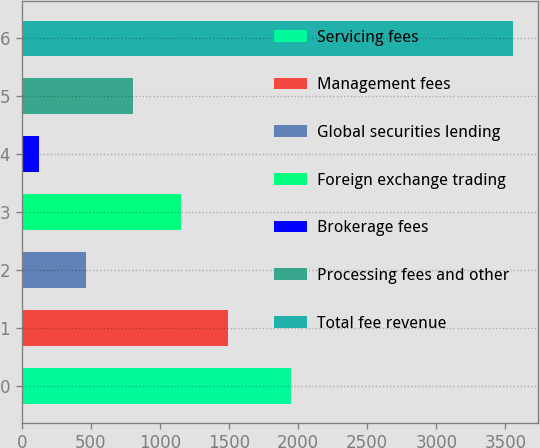Convert chart to OTSL. <chart><loc_0><loc_0><loc_500><loc_500><bar_chart><fcel>Servicing fees<fcel>Management fees<fcel>Global securities lending<fcel>Foreign exchange trading<fcel>Brokerage fees<fcel>Processing fees and other<fcel>Total fee revenue<nl><fcel>1950<fcel>1495.6<fcel>465.4<fcel>1152.2<fcel>122<fcel>808.8<fcel>3556<nl></chart> 